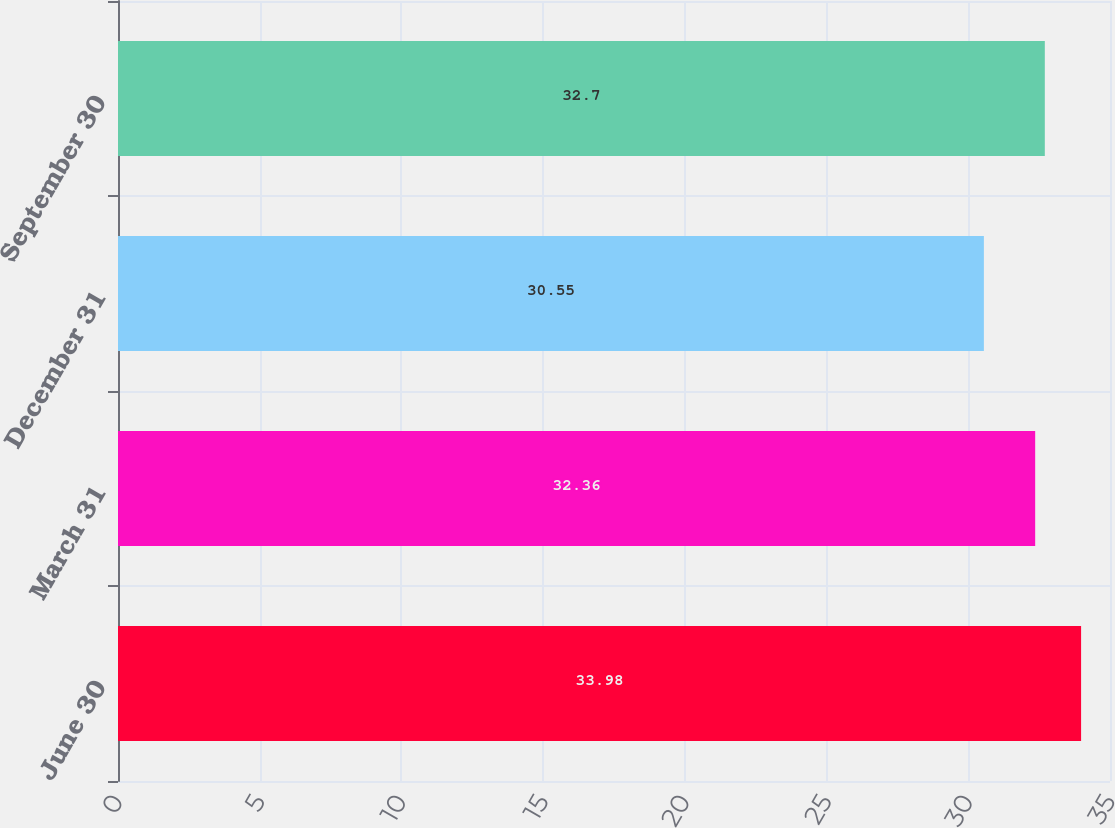Convert chart to OTSL. <chart><loc_0><loc_0><loc_500><loc_500><bar_chart><fcel>June 30<fcel>March 31<fcel>December 31<fcel>September 30<nl><fcel>33.98<fcel>32.36<fcel>30.55<fcel>32.7<nl></chart> 